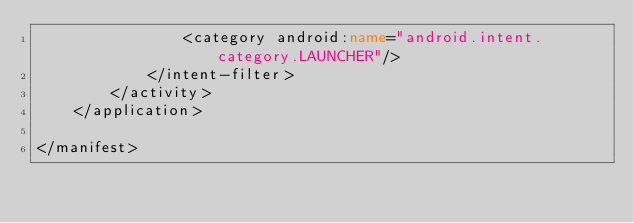<code> <loc_0><loc_0><loc_500><loc_500><_XML_>                <category android:name="android.intent.category.LAUNCHER"/>
            </intent-filter>
        </activity>
    </application>

</manifest></code> 